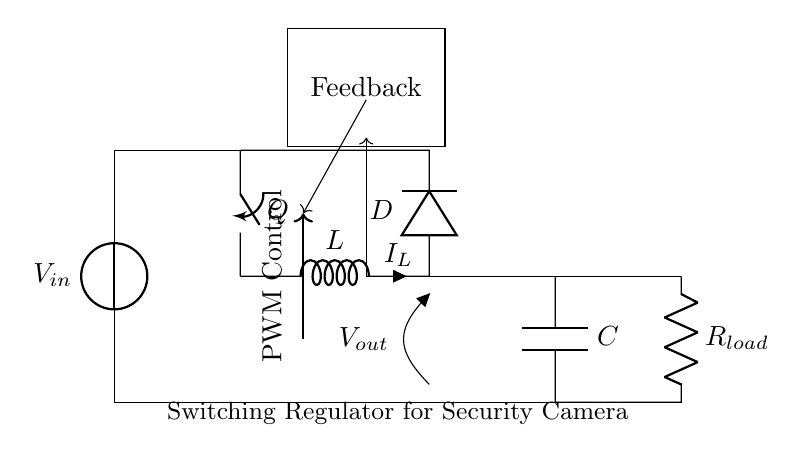What is the input voltage of the circuit? The input voltage is labeled as V_in at the voltage source. This is the power supply voltage that feeds into the circuit.
Answer: V_in What component provides feedback in this circuit? The feedback component is located in the rectangle on the top left labeled "Feedback." This indicates that it is part of the control loop to regulate the output voltage.
Answer: Feedback What is the purpose of the inductor in this circuit? The inductor, labeled as L, stores energy when the switch Q is closed and releases it to maintain current flow when the switch is open. This helps in smoothing the output voltage.
Answer: Energy storage Which component is used for the current flow to the load? The resistor R_load, located at the bottom right, is connected to the output voltage and represents the load in this circuit, allowing current to flow through it.
Answer: R_load What type of control is utilized in this switching regulator? The PWM control is indicated by the arrow and notation inside the circuit. This stands for Pulse Width Modulation, which is used to control the switch Q and regulate the output voltage effectively.
Answer: PWM Control How does the diode function in this circuit? The diode, labeled as D, allows current to flow only in one direction and prevents backflow when the switch Q opens. This ensures that the output capacitor C can discharge into the load properly.
Answer: Prevents backflow 